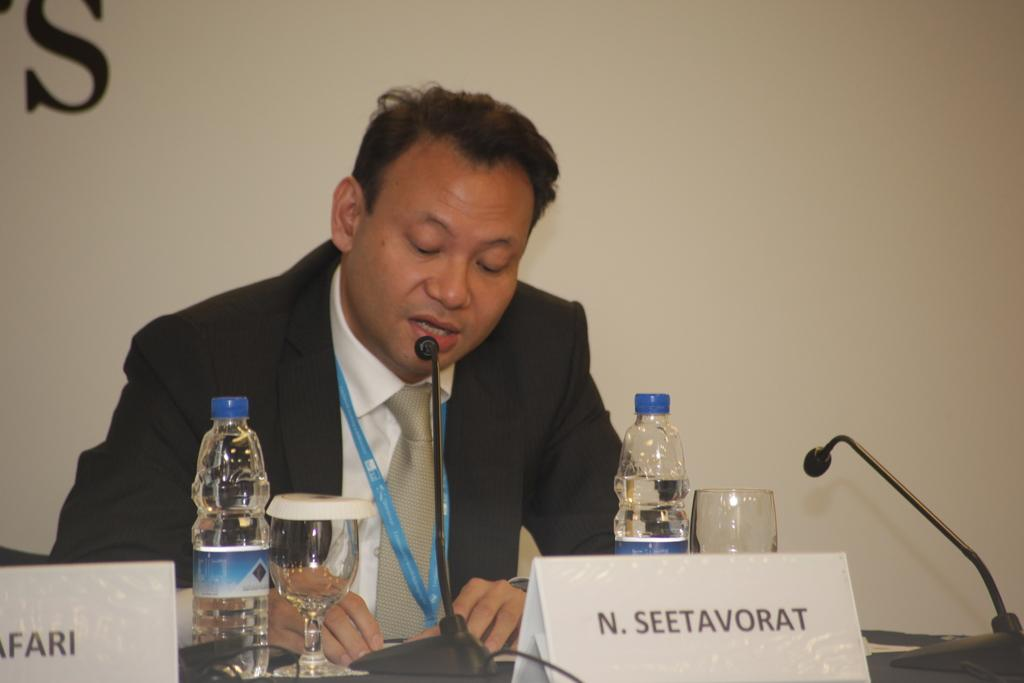What is the man in the image doing? The man is sitting in the image. What objects are on the table in the image? There are bottles, microphones, glasses, and name plates on the table in the image. What is the background of the image? There is a wall in the background of the image. What type of pig can be seen reading prose in the image? There is no pig or prose present in the image. What color is the thread used to sew the name plates in the image? There is no thread mentioned or visible in the image. 